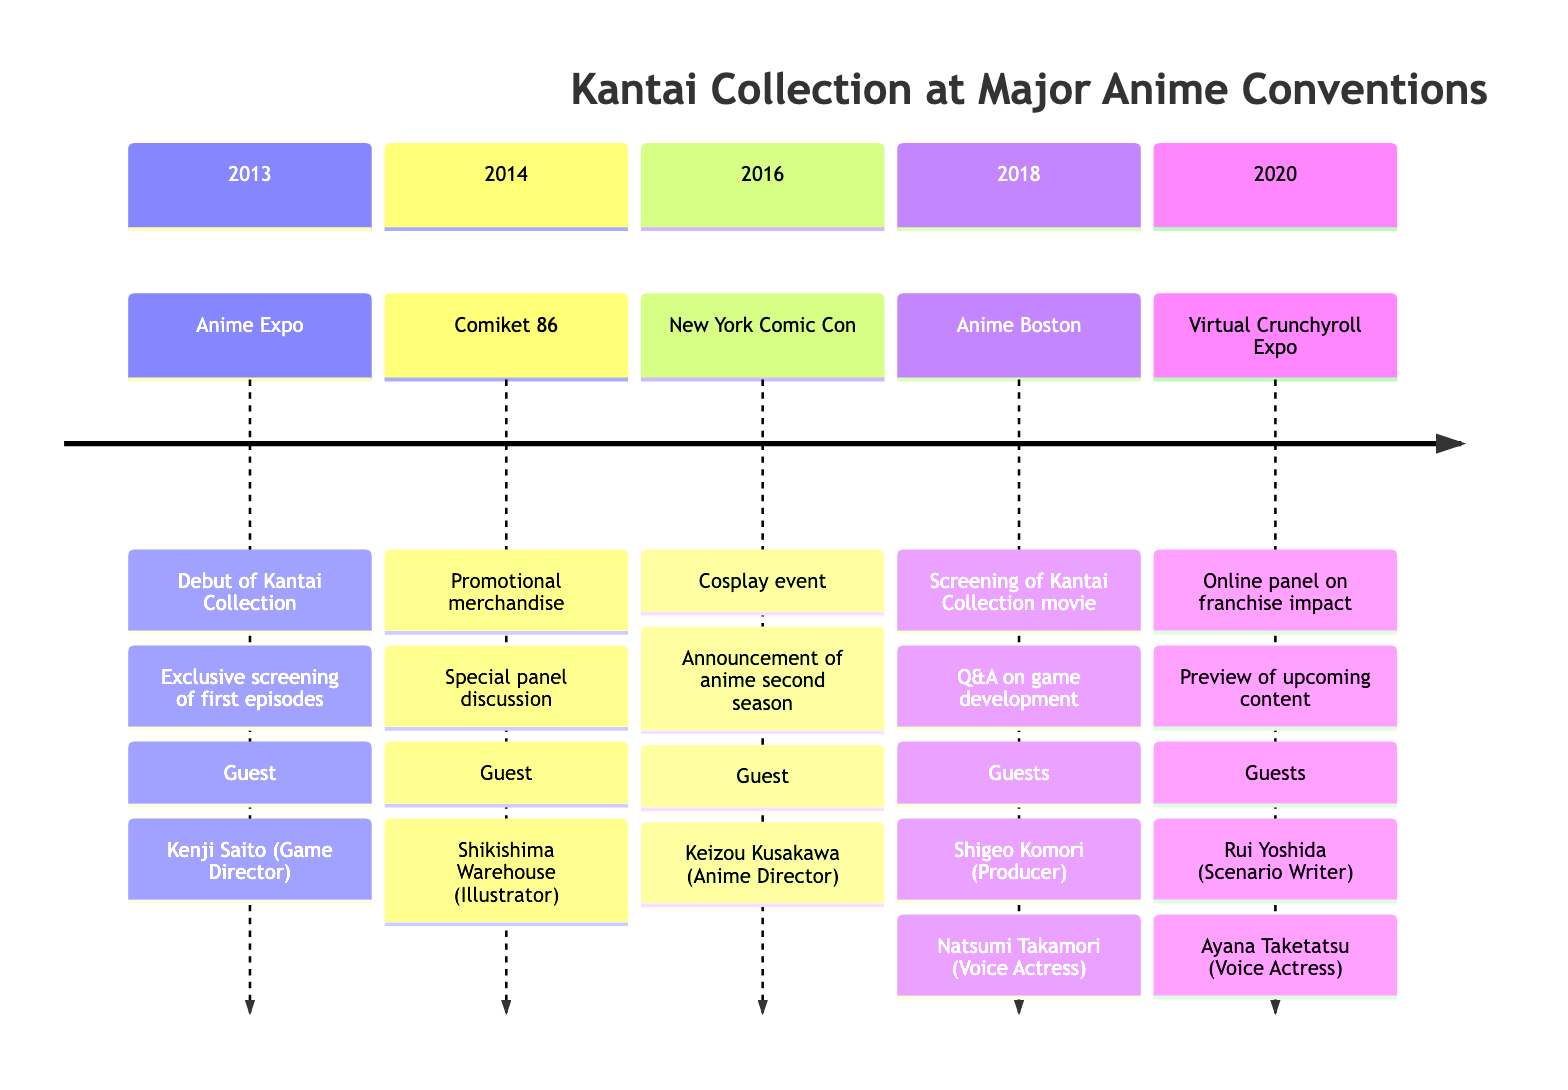What's the first convention listed in the timeline? The first entry in the timeline is for the year 2013, which is identified as Anime Expo.
Answer: Anime Expo How many guests appeared in total at the 2018 Anime Boston? The 2018 Anime Boston entry lists two guests: Shigeo Komori and Natsumi Takamori, so we count them to find the total.
Answer: 2 What major announcement was made at the 2016 New York Comic Con? The timeline shows that the announcement made at the 2016 convention was about the second season of the Kantai Collection anime.
Answer: Announcement of Kantai Collection anime second season Which guest appeared at the Virtual Crunchyroll Expo in 2020? Looking at the 2020 entry, it includes two guests: Rui Yoshida and Ayana Taketatsu. Thus, any of these could be correct.
Answer: Rui Yoshida (or Ayana Taketatsu) In which year did the Kantai Collection movie screening occur? By reviewing the entries, the screening of the Kantai Collection movie is specifically noted under the 2018 Anime Boston.
Answer: 2018 What type of event took place at Anime Expo in 2013? The 2013 entry describes two events, but if we focus on the debut mentioned, this indicates it was an important launch event.
Answer: Debut Which convention featured both a panel discussion and promotional merchandise? The information indicates that the 2014 Comiket 86 featured both a special panel discussion and promotional merchandise for Kantai Collection.
Answer: Comiket 86 What unique format did the 2020 convention take? According to the timeline, the 2020 event was a Virtual Crunchyroll Expo, indicating it was held online.
Answer: Virtual How many years apart are Anime Boston 2018 and New York Comic Con 2016? By calculating the years, we find that Anime Boston occurred two years after New York Comic Con.
Answer: 2 